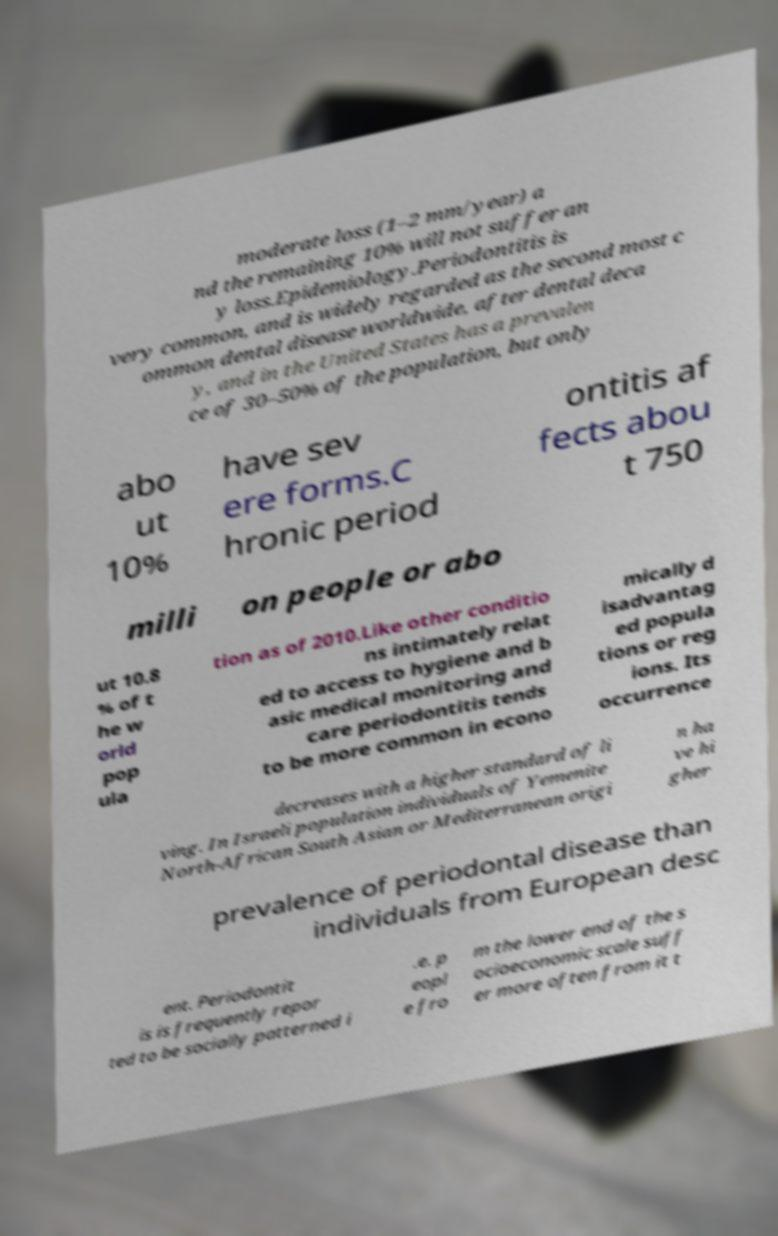What messages or text are displayed in this image? I need them in a readable, typed format. moderate loss (1–2 mm/year) a nd the remaining 10% will not suffer an y loss.Epidemiology.Periodontitis is very common, and is widely regarded as the second most c ommon dental disease worldwide, after dental deca y, and in the United States has a prevalen ce of 30–50% of the population, but only abo ut 10% have sev ere forms.C hronic period ontitis af fects abou t 750 milli on people or abo ut 10.8 % of t he w orld pop ula tion as of 2010.Like other conditio ns intimately relat ed to access to hygiene and b asic medical monitoring and care periodontitis tends to be more common in econo mically d isadvantag ed popula tions or reg ions. Its occurrence decreases with a higher standard of li ving. In Israeli population individuals of Yemenite North-African South Asian or Mediterranean origi n ha ve hi gher prevalence of periodontal disease than individuals from European desc ent. Periodontit is is frequently repor ted to be socially patterned i .e. p eopl e fro m the lower end of the s ocioeconomic scale suff er more often from it t 